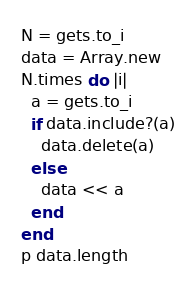<code> <loc_0><loc_0><loc_500><loc_500><_Ruby_>N = gets.to_i
data = Array.new
N.times do |i|
  a = gets.to_i
  if data.include?(a)
    data.delete(a)
  else
    data << a
  end
end
p data.length</code> 